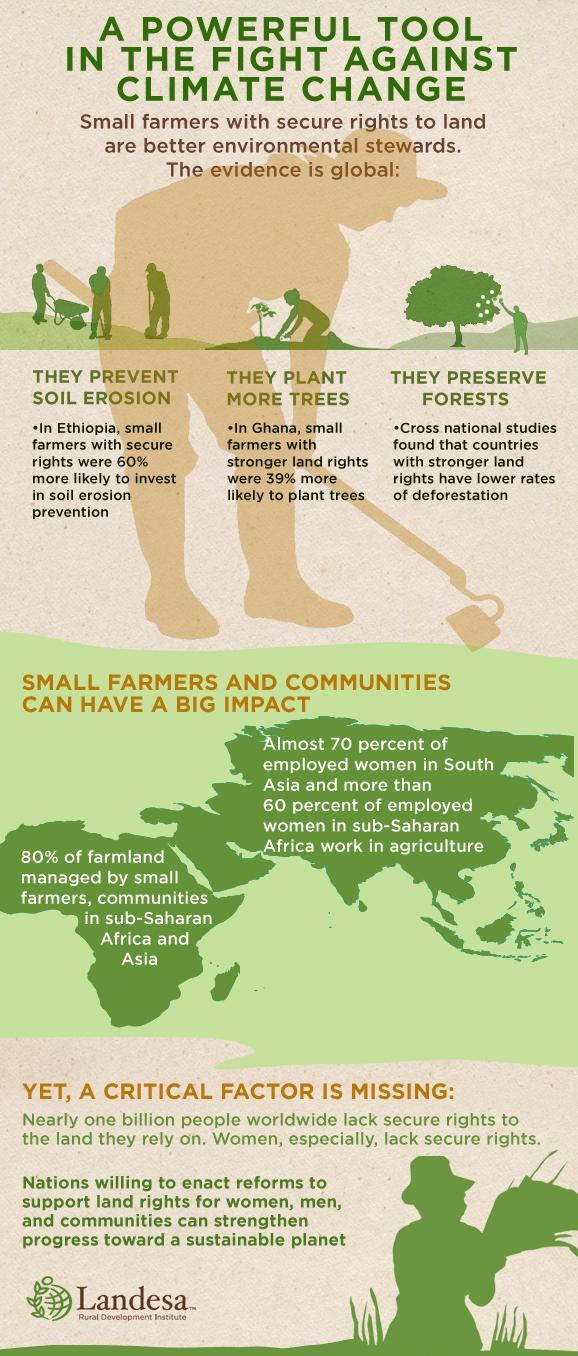Specify some key components in this picture. Most small farmer communities belonged to Africa and Asia, which were the continents that housed the largest number of these communities. 